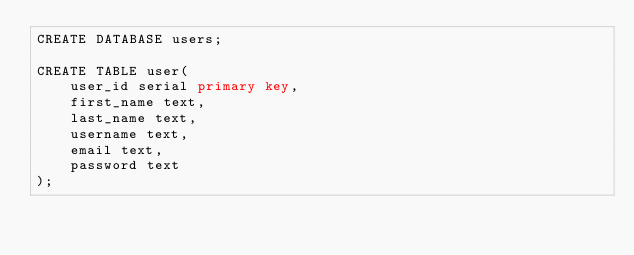Convert code to text. <code><loc_0><loc_0><loc_500><loc_500><_SQL_>CREATE DATABASE users;

CREATE TABLE user(
    user_id serial primary key,
    first_name text,
    last_name text,
    username text,
    email text,
    password text
);</code> 